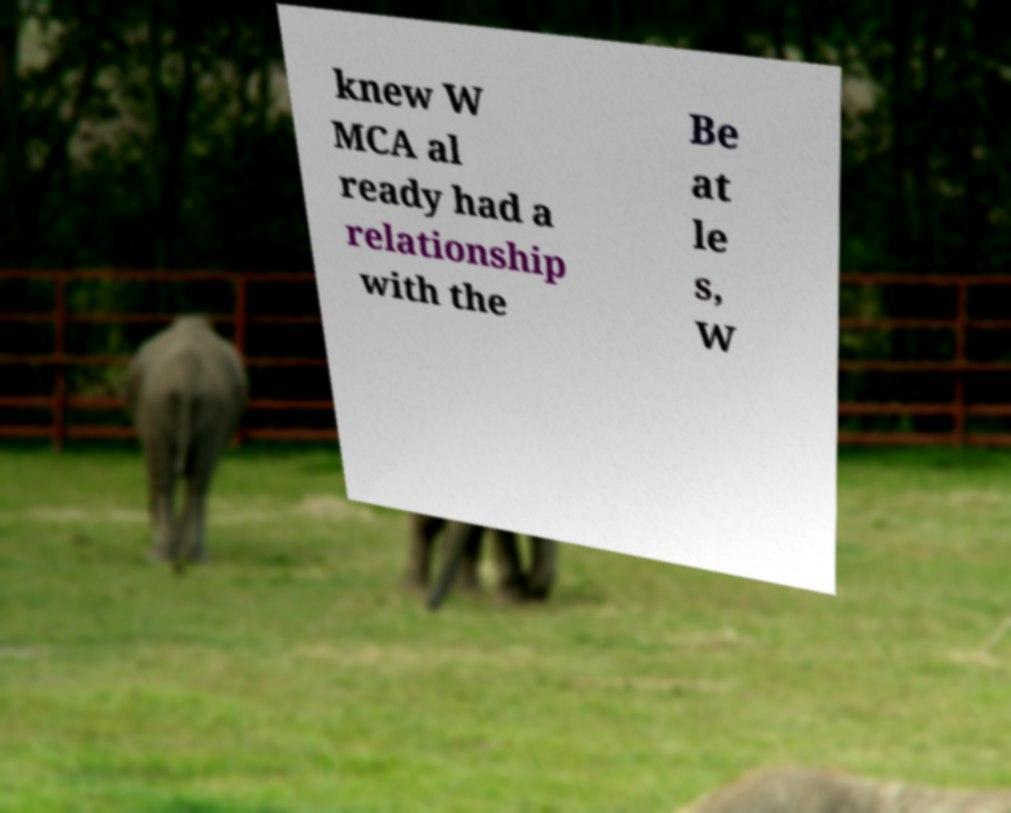Can you accurately transcribe the text from the provided image for me? knew W MCA al ready had a relationship with the Be at le s, W 